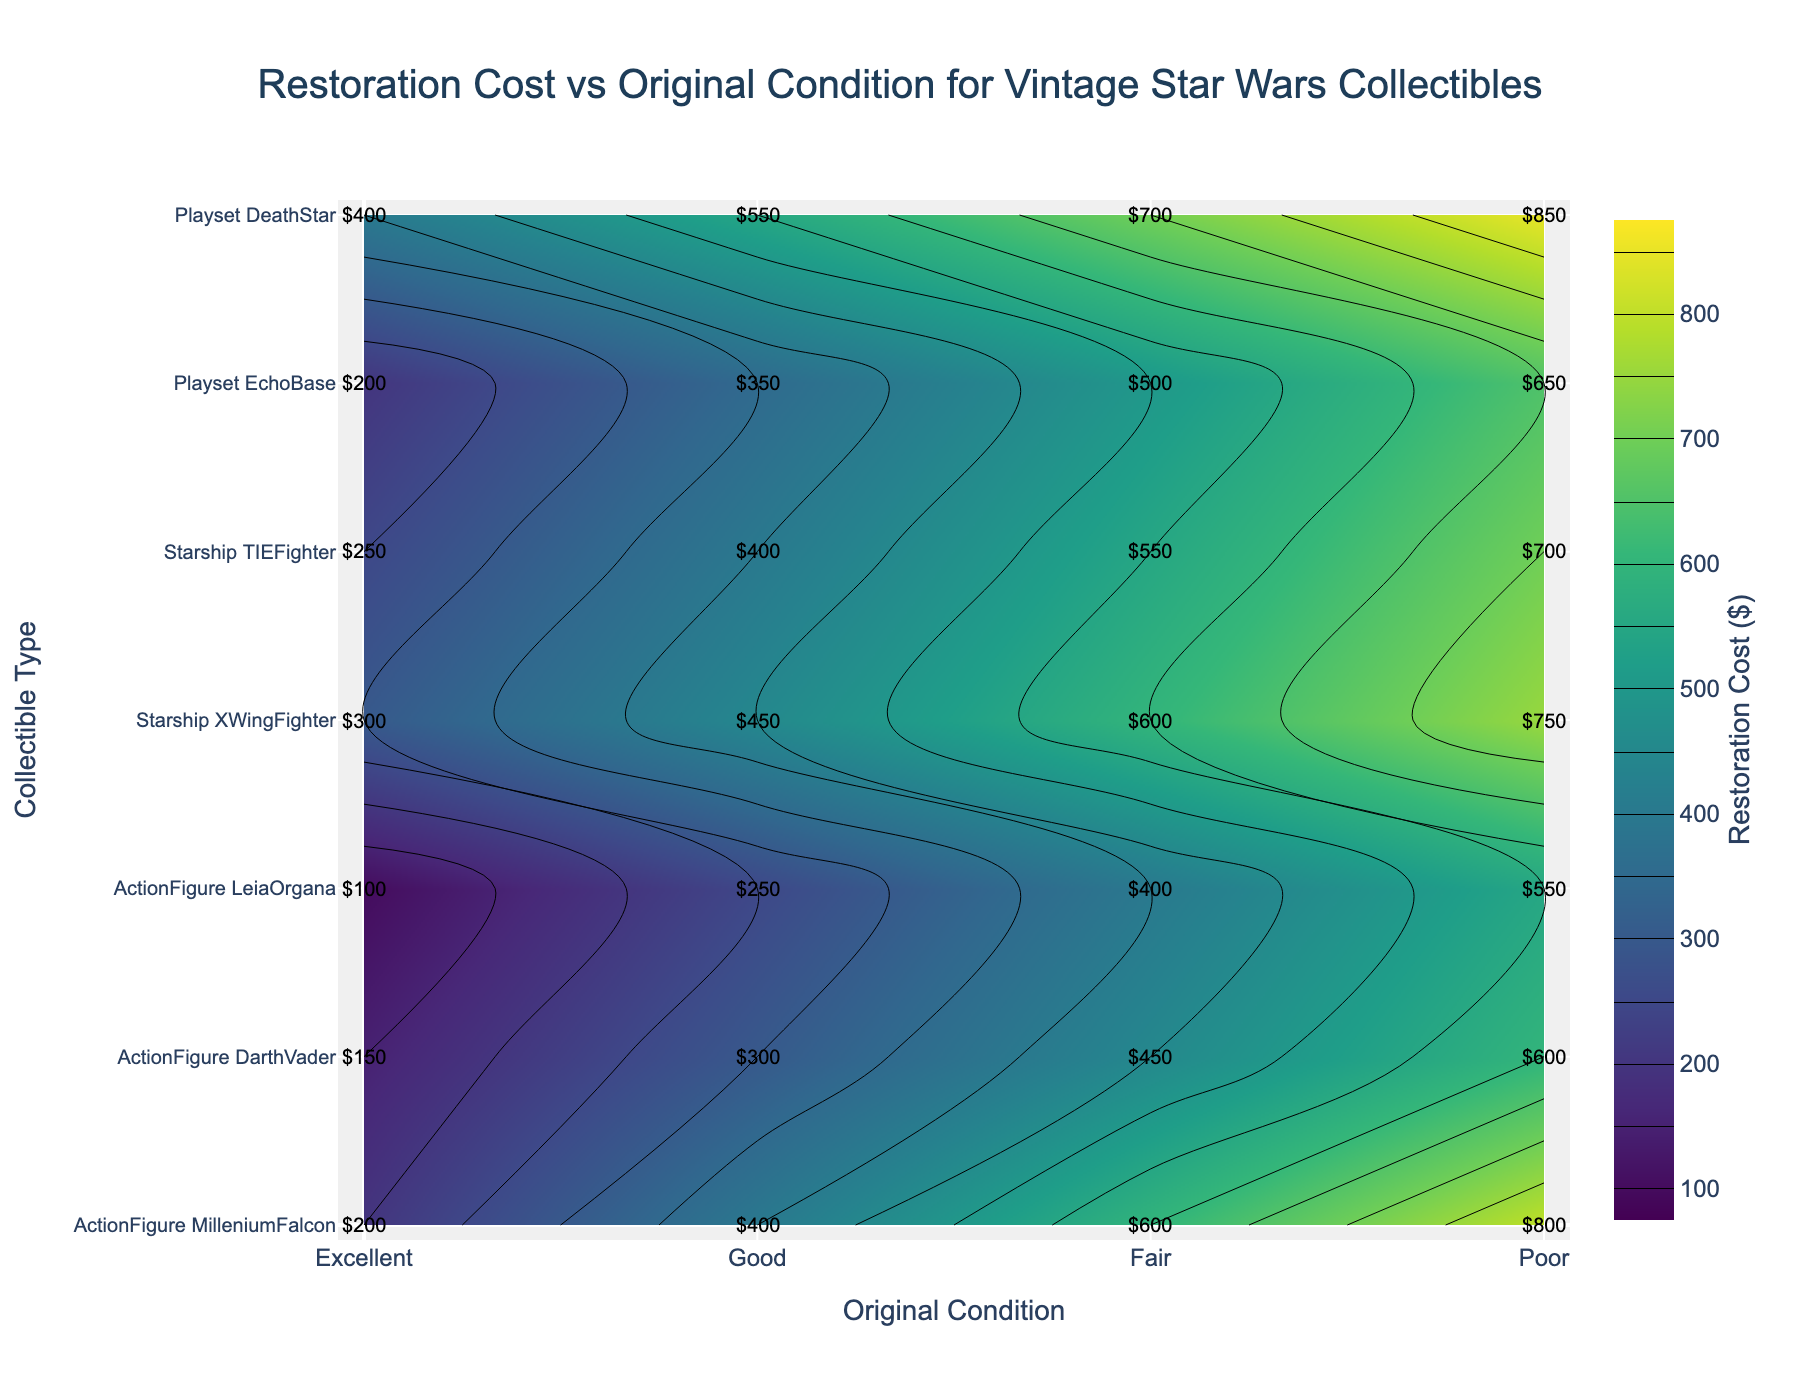What's the title of the figure? The title of the figure is typically found at the top of the plot. It is often the most prominent text besides the labels and axis titles.
Answer: Restoration Cost vs Original Condition for Vintage Star Wars Collectibles How are the original conditions represented on the x-axis? The original conditions are represented by labels like 'Excellent,' 'Good,' 'Fair,' and 'Poor' on the x-axis. These are evenly spaced along the x-axis, creating four distinct categories.
Answer: By labels: Excellent, Good, Fair, Poor Which collectible type has the highest restoration cost when in Excellent condition? To find the highest restoration cost for an 'Excellent' condition, we look at the values labeled 'Excellent' on the y-axis and identify the maximum cost among them.
Answer: Playset Death Star What is the restoration cost for a TIE Fighter in Poor condition? Locate 'TIE Fighter' on the y-axis and follow the contour line to where it intersects with the 'Poor' condition on the x-axis. The labeled cost at this point is the restoration cost.
Answer: $700 Which condition has the lowest restoration cost for an Action Figure Millennium Falcon? Examine the costs for the 'Action Figure Millennium Falcon' across different conditions. The lowest value indicates the condition with the lowest restoration cost.
Answer: Excellent condition How much more does it cost to restore an Echo Base Playset in Poor condition compared to Fair condition? Find the restoration costs for both 'Poor' and 'Fair' conditions of an Echo Base Playset and subtract the Fair condition cost from the Poor condition cost.
Answer: $650 - $500 = $150 What is the average restoration cost for an X-Wing Fighter across all conditions? To find the average, sum up the restoration costs for an X-Wing Fighter across all conditions and then divide by the number of conditions (4).
Answer: ($300 + $450 + $600 + $750) / 4 = $525 Which has a higher restoration cost in Good condition: Darth Vader Action Figure or Echo Base Playset? Compare the restoration costs for 'Good' conditions of both the Darth Vader Action Figure and Echo Base Playset.
Answer: Echo Base Playset Between Leia Organa and X-Wing Fighter, which has the greater increase in restoration cost from Excellent to Poor conditions? Calculate the difference in restoration costs from 'Excellent' to 'Poor' for both Leia Organa and X-Wing Fighter, and compare the differences.
Answer: X-Wing Fighter How is the color used to represent different restoration costs in the plot? The plot uses a colorscale (Viridis) to represent different restoration costs. Darker colors indicate lower costs, and lighter colors indicate higher costs.
Answer: Darker colors for lower costs, lighter colors for higher costs 